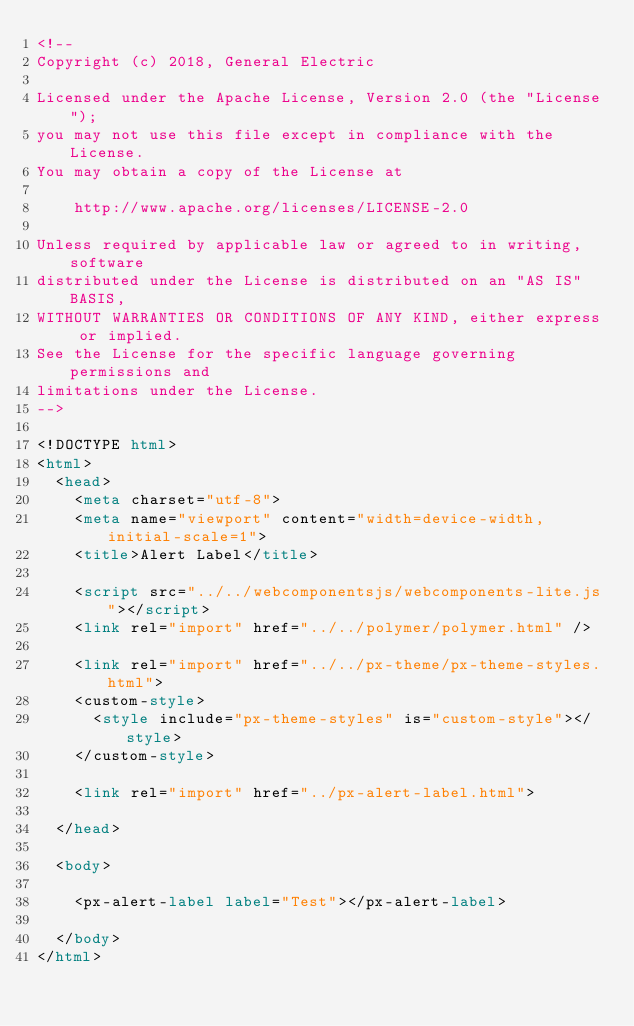Convert code to text. <code><loc_0><loc_0><loc_500><loc_500><_HTML_><!--
Copyright (c) 2018, General Electric

Licensed under the Apache License, Version 2.0 (the "License");
you may not use this file except in compliance with the License.
You may obtain a copy of the License at

    http://www.apache.org/licenses/LICENSE-2.0

Unless required by applicable law or agreed to in writing, software
distributed under the License is distributed on an "AS IS" BASIS,
WITHOUT WARRANTIES OR CONDITIONS OF ANY KIND, either express or implied.
See the License for the specific language governing permissions and
limitations under the License.
-->

<!DOCTYPE html>
<html>
  <head>
    <meta charset="utf-8">
    <meta name="viewport" content="width=device-width, initial-scale=1">
    <title>Alert Label</title>

    <script src="../../webcomponentsjs/webcomponents-lite.js"></script>
    <link rel="import" href="../../polymer/polymer.html" />

    <link rel="import" href="../../px-theme/px-theme-styles.html">
    <custom-style>
      <style include="px-theme-styles" is="custom-style"></style>
    </custom-style>

    <link rel="import" href="../px-alert-label.html">

  </head>

  <body>

    <px-alert-label label="Test"></px-alert-label>

  </body>
</html>
</code> 